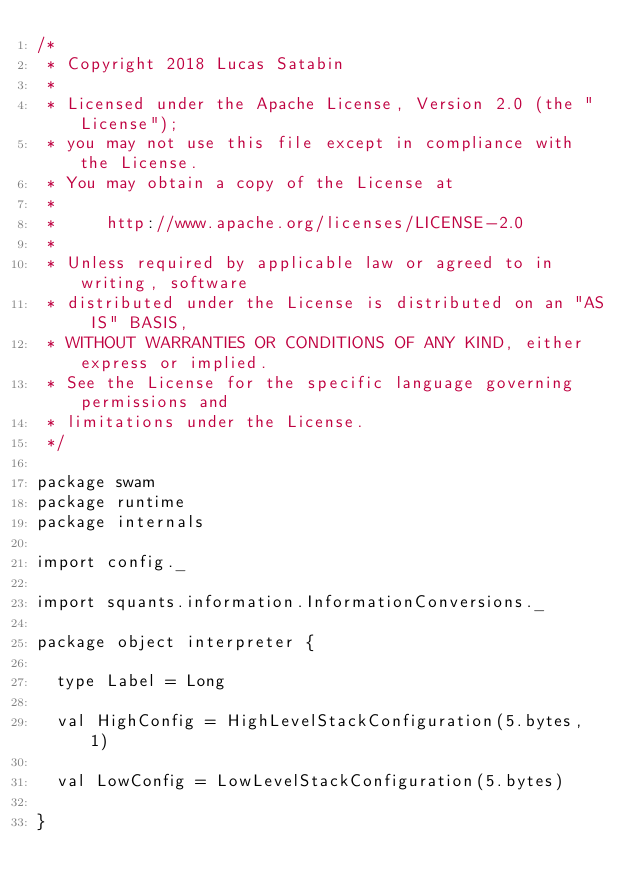Convert code to text. <code><loc_0><loc_0><loc_500><loc_500><_Scala_>/*
 * Copyright 2018 Lucas Satabin
 *
 * Licensed under the Apache License, Version 2.0 (the "License");
 * you may not use this file except in compliance with the License.
 * You may obtain a copy of the License at
 *
 *     http://www.apache.org/licenses/LICENSE-2.0
 *
 * Unless required by applicable law or agreed to in writing, software
 * distributed under the License is distributed on an "AS IS" BASIS,
 * WITHOUT WARRANTIES OR CONDITIONS OF ANY KIND, either express or implied.
 * See the License for the specific language governing permissions and
 * limitations under the License.
 */

package swam
package runtime
package internals

import config._

import squants.information.InformationConversions._

package object interpreter {

  type Label = Long

  val HighConfig = HighLevelStackConfiguration(5.bytes, 1)

  val LowConfig = LowLevelStackConfiguration(5.bytes)

}
</code> 